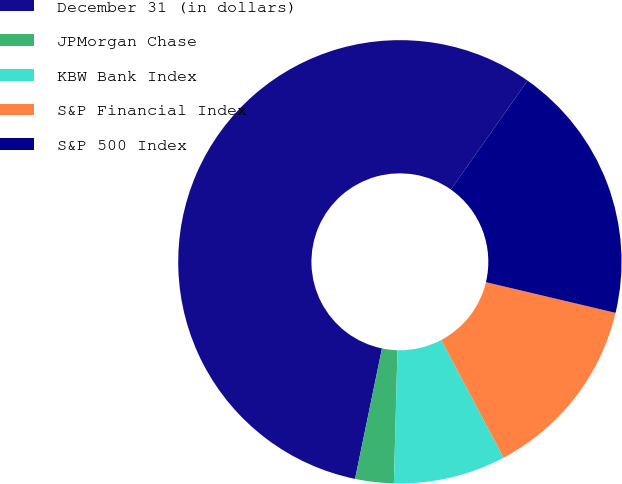Convert chart. <chart><loc_0><loc_0><loc_500><loc_500><pie_chart><fcel>December 31 (in dollars)<fcel>JPMorgan Chase<fcel>KBW Bank Index<fcel>S&P Financial Index<fcel>S&P 500 Index<nl><fcel>56.53%<fcel>2.81%<fcel>8.18%<fcel>13.55%<fcel>18.93%<nl></chart> 